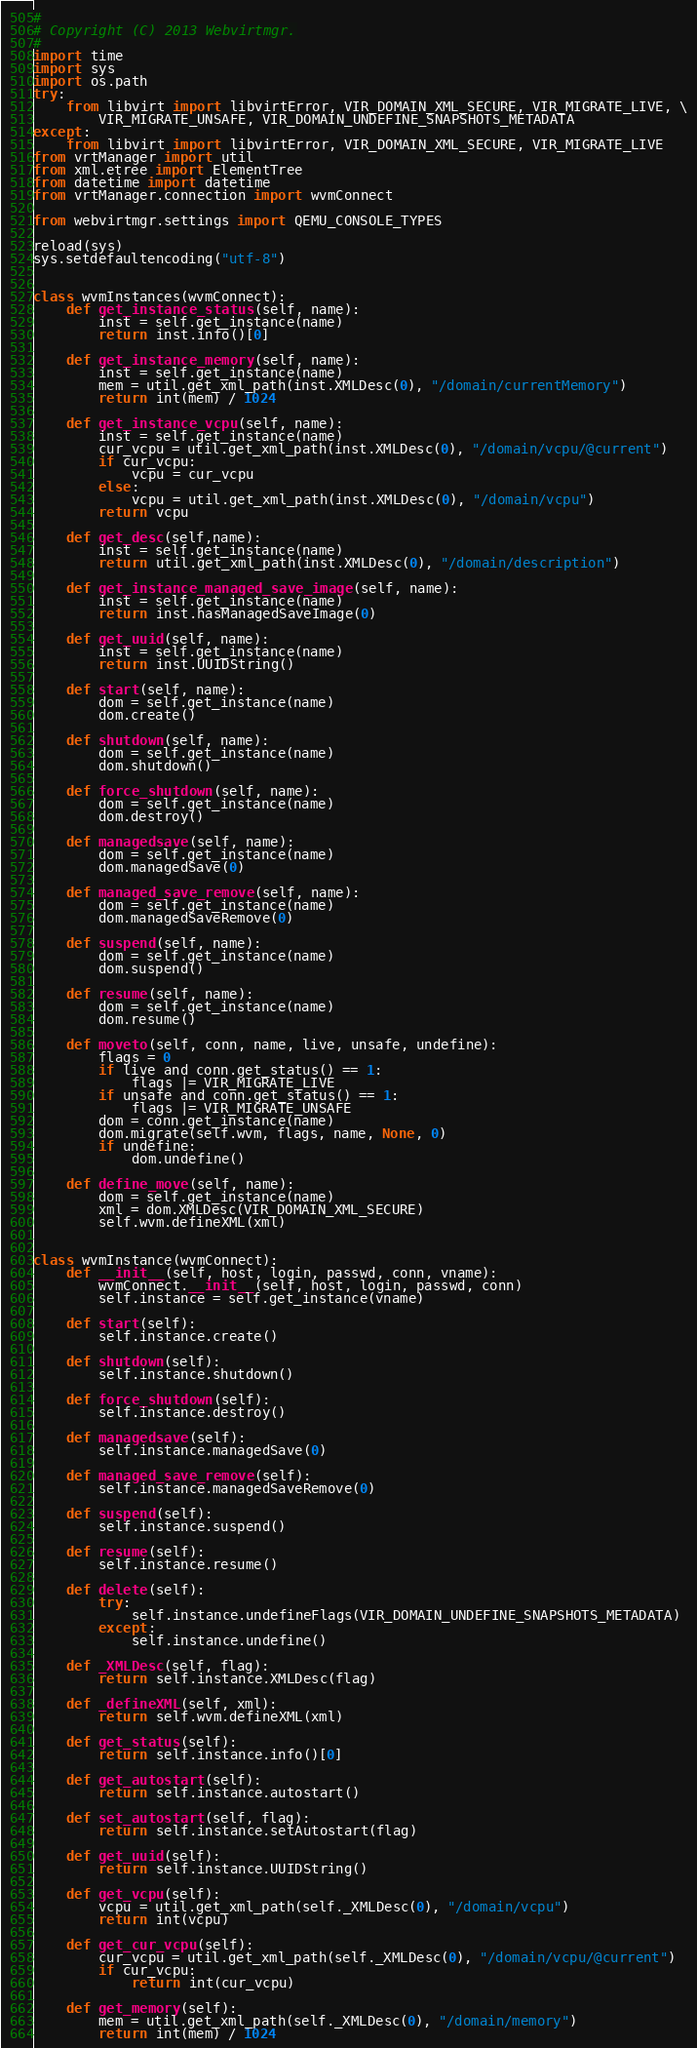Convert code to text. <code><loc_0><loc_0><loc_500><loc_500><_Python_>#
# Copyright (C) 2013 Webvirtmgr.
#
import time
import sys
import os.path
try:
    from libvirt import libvirtError, VIR_DOMAIN_XML_SECURE, VIR_MIGRATE_LIVE, \
        VIR_MIGRATE_UNSAFE, VIR_DOMAIN_UNDEFINE_SNAPSHOTS_METADATA
except:
    from libvirt import libvirtError, VIR_DOMAIN_XML_SECURE, VIR_MIGRATE_LIVE
from vrtManager import util
from xml.etree import ElementTree
from datetime import datetime
from vrtManager.connection import wvmConnect

from webvirtmgr.settings import QEMU_CONSOLE_TYPES

reload(sys)
sys.setdefaultencoding("utf-8")


class wvmInstances(wvmConnect):
    def get_instance_status(self, name):
        inst = self.get_instance(name)
        return inst.info()[0]

    def get_instance_memory(self, name):
        inst = self.get_instance(name)
        mem = util.get_xml_path(inst.XMLDesc(0), "/domain/currentMemory")
        return int(mem) / 1024

    def get_instance_vcpu(self, name):
        inst = self.get_instance(name)
        cur_vcpu = util.get_xml_path(inst.XMLDesc(0), "/domain/vcpu/@current")
        if cur_vcpu:
            vcpu = cur_vcpu
        else:
            vcpu = util.get_xml_path(inst.XMLDesc(0), "/domain/vcpu")
        return vcpu
   
    def get_desc(self,name):
        inst = self.get_instance(name)
        return util.get_xml_path(inst.XMLDesc(0), "/domain/description")
 
    def get_instance_managed_save_image(self, name):
        inst = self.get_instance(name)
        return inst.hasManagedSaveImage(0)

    def get_uuid(self, name):
        inst = self.get_instance(name)
        return inst.UUIDString()

    def start(self, name):
        dom = self.get_instance(name)
        dom.create()

    def shutdown(self, name):
        dom = self.get_instance(name)
        dom.shutdown()

    def force_shutdown(self, name):
        dom = self.get_instance(name)
        dom.destroy()

    def managedsave(self, name):
        dom = self.get_instance(name)
        dom.managedSave(0)

    def managed_save_remove(self, name):
        dom = self.get_instance(name)
        dom.managedSaveRemove(0)

    def suspend(self, name):
        dom = self.get_instance(name)
        dom.suspend()

    def resume(self, name):
        dom = self.get_instance(name)
        dom.resume()

    def moveto(self, conn, name, live, unsafe, undefine):
        flags = 0
        if live and conn.get_status() == 1:
            flags |= VIR_MIGRATE_LIVE
        if unsafe and conn.get_status() == 1:
            flags |= VIR_MIGRATE_UNSAFE
        dom = conn.get_instance(name)
        dom.migrate(self.wvm, flags, name, None, 0)
        if undefine:
            dom.undefine()

    def define_move(self, name):
        dom = self.get_instance(name)
        xml = dom.XMLDesc(VIR_DOMAIN_XML_SECURE)
        self.wvm.defineXML(xml)


class wvmInstance(wvmConnect):
    def __init__(self, host, login, passwd, conn, vname):
        wvmConnect.__init__(self, host, login, passwd, conn)
        self.instance = self.get_instance(vname)

    def start(self):
        self.instance.create()

    def shutdown(self):
        self.instance.shutdown()

    def force_shutdown(self):
        self.instance.destroy()

    def managedsave(self):
        self.instance.managedSave(0)

    def managed_save_remove(self):
        self.instance.managedSaveRemove(0)

    def suspend(self):
        self.instance.suspend()

    def resume(self):
        self.instance.resume()

    def delete(self):
        try:
            self.instance.undefineFlags(VIR_DOMAIN_UNDEFINE_SNAPSHOTS_METADATA)
        except:
            self.instance.undefine()

    def _XMLDesc(self, flag):
        return self.instance.XMLDesc(flag)

    def _defineXML(self, xml):
        return self.wvm.defineXML(xml)

    def get_status(self):
        return self.instance.info()[0]

    def get_autostart(self):
        return self.instance.autostart()

    def set_autostart(self, flag):
        return self.instance.setAutostart(flag)

    def get_uuid(self):
        return self.instance.UUIDString()

    def get_vcpu(self):
        vcpu = util.get_xml_path(self._XMLDesc(0), "/domain/vcpu")
        return int(vcpu)

    def get_cur_vcpu(self):
        cur_vcpu = util.get_xml_path(self._XMLDesc(0), "/domain/vcpu/@current")
        if cur_vcpu:
            return int(cur_vcpu)

    def get_memory(self):
        mem = util.get_xml_path(self._XMLDesc(0), "/domain/memory")
        return int(mem) / 1024
</code> 